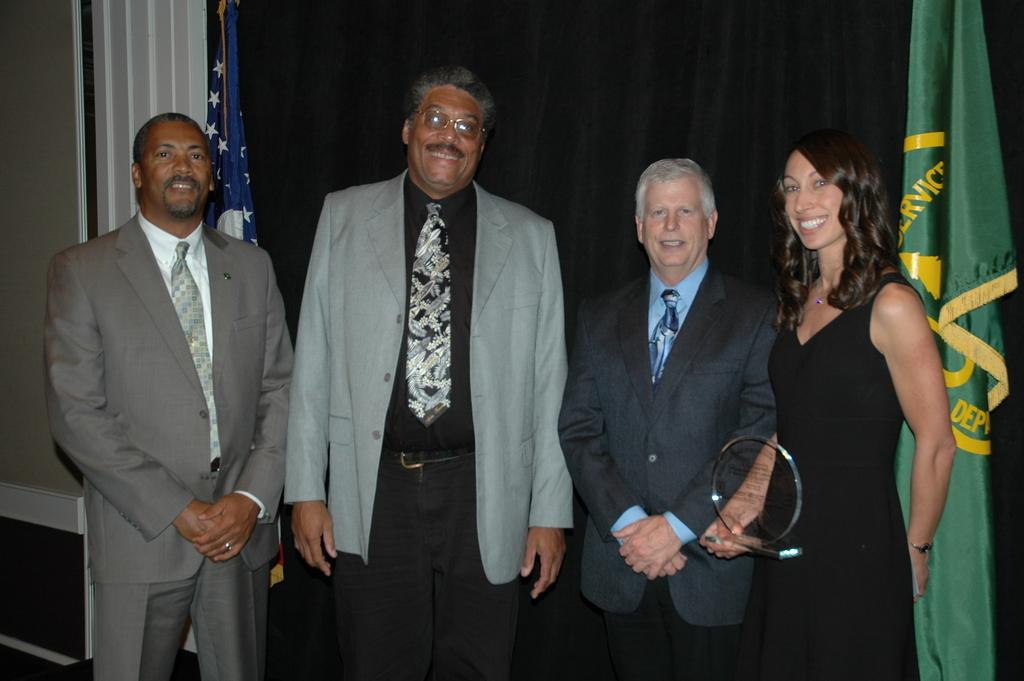What are the people in the image doing? The people in the image are standing and smiling. Can you describe any actions or objects related to the people? One person is carrying an object. What can be seen in the background of the image? There are flags and a curtain in the background of the image. What type of toothpaste is being advertised on the stage in the image? There is no toothpaste or stage present in the image. What kind of plantation can be seen in the background of the image? There is no plantation visible in the image; it features flags and a curtain in the background. 